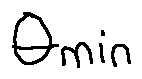<formula> <loc_0><loc_0><loc_500><loc_500>\theta _ { \min }</formula> 